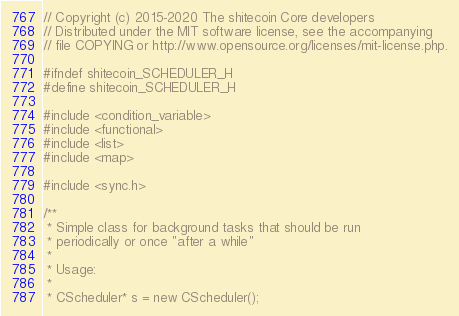<code> <loc_0><loc_0><loc_500><loc_500><_C_>// Copyright (c) 2015-2020 The shitecoin Core developers
// Distributed under the MIT software license, see the accompanying
// file COPYING or http://www.opensource.org/licenses/mit-license.php.

#ifndef shitecoin_SCHEDULER_H
#define shitecoin_SCHEDULER_H

#include <condition_variable>
#include <functional>
#include <list>
#include <map>

#include <sync.h>

/**
 * Simple class for background tasks that should be run
 * periodically or once "after a while"
 *
 * Usage:
 *
 * CScheduler* s = new CScheduler();</code> 